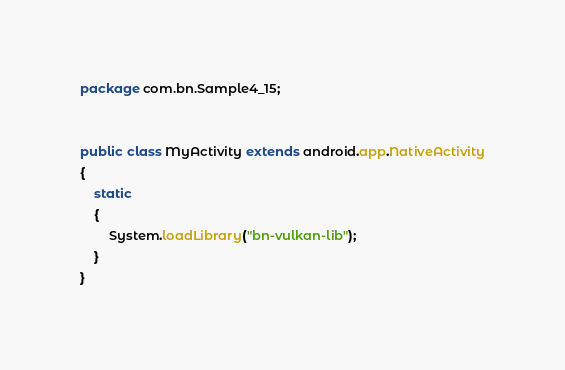<code> <loc_0><loc_0><loc_500><loc_500><_Java_>package com.bn.Sample4_15;


public class MyActivity extends android.app.NativeActivity
{
    static
    {
        System.loadLibrary("bn-vulkan-lib");
    }
}
</code> 